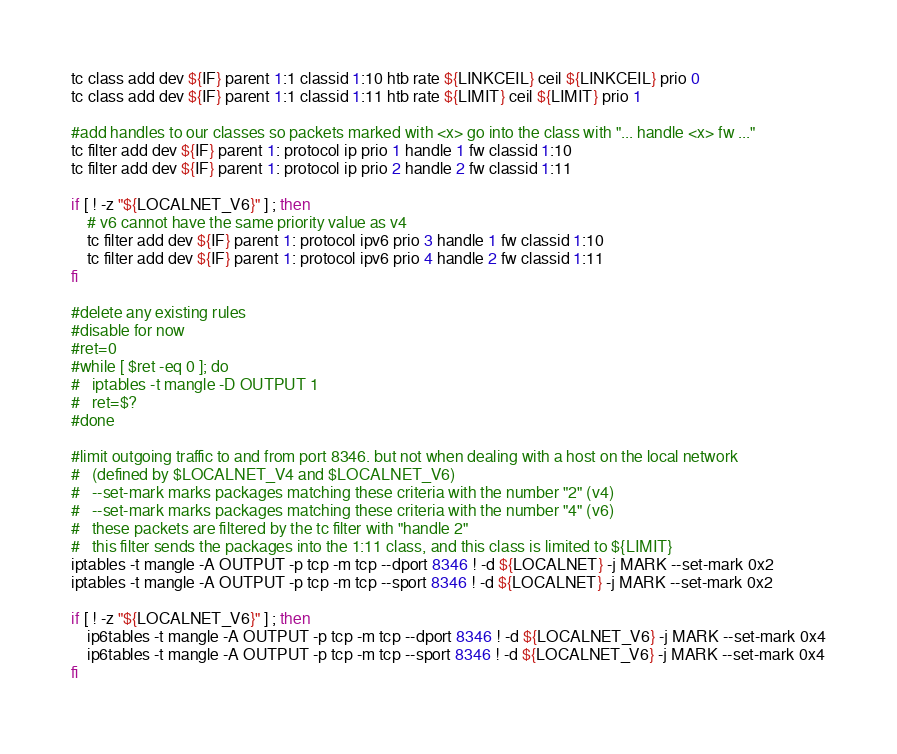<code> <loc_0><loc_0><loc_500><loc_500><_Bash_>tc class add dev ${IF} parent 1:1 classid 1:10 htb rate ${LINKCEIL} ceil ${LINKCEIL} prio 0
tc class add dev ${IF} parent 1:1 classid 1:11 htb rate ${LIMIT} ceil ${LIMIT} prio 1

#add handles to our classes so packets marked with <x> go into the class with "... handle <x> fw ..."
tc filter add dev ${IF} parent 1: protocol ip prio 1 handle 1 fw classid 1:10
tc filter add dev ${IF} parent 1: protocol ip prio 2 handle 2 fw classid 1:11

if [ ! -z "${LOCALNET_V6}" ] ; then
	# v6 cannot have the same priority value as v4
	tc filter add dev ${IF} parent 1: protocol ipv6 prio 3 handle 1 fw classid 1:10
	tc filter add dev ${IF} parent 1: protocol ipv6 prio 4 handle 2 fw classid 1:11
fi

#delete any existing rules
#disable for now
#ret=0
#while [ $ret -eq 0 ]; do
#	iptables -t mangle -D OUTPUT 1
#	ret=$?
#done

#limit outgoing traffic to and from port 8346. but not when dealing with a host on the local network
#	(defined by $LOCALNET_V4 and $LOCALNET_V6)
#	--set-mark marks packages matching these criteria with the number "2" (v4)
#	--set-mark marks packages matching these criteria with the number "4" (v6)
#	these packets are filtered by the tc filter with "handle 2"
#	this filter sends the packages into the 1:11 class, and this class is limited to ${LIMIT}
iptables -t mangle -A OUTPUT -p tcp -m tcp --dport 8346 ! -d ${LOCALNET} -j MARK --set-mark 0x2
iptables -t mangle -A OUTPUT -p tcp -m tcp --sport 8346 ! -d ${LOCALNET} -j MARK --set-mark 0x2

if [ ! -z "${LOCALNET_V6}" ] ; then
	ip6tables -t mangle -A OUTPUT -p tcp -m tcp --dport 8346 ! -d ${LOCALNET_V6} -j MARK --set-mark 0x4
	ip6tables -t mangle -A OUTPUT -p tcp -m tcp --sport 8346 ! -d ${LOCALNET_V6} -j MARK --set-mark 0x4
fi
</code> 